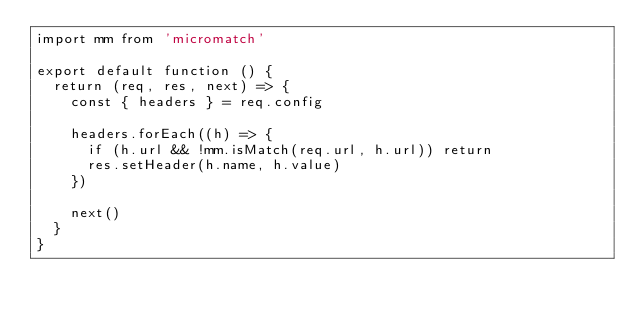<code> <loc_0><loc_0><loc_500><loc_500><_JavaScript_>import mm from 'micromatch'

export default function () {
  return (req, res, next) => {
    const { headers } = req.config

    headers.forEach((h) => {
      if (h.url && !mm.isMatch(req.url, h.url)) return
      res.setHeader(h.name, h.value)
    })

    next()
  }
}
</code> 